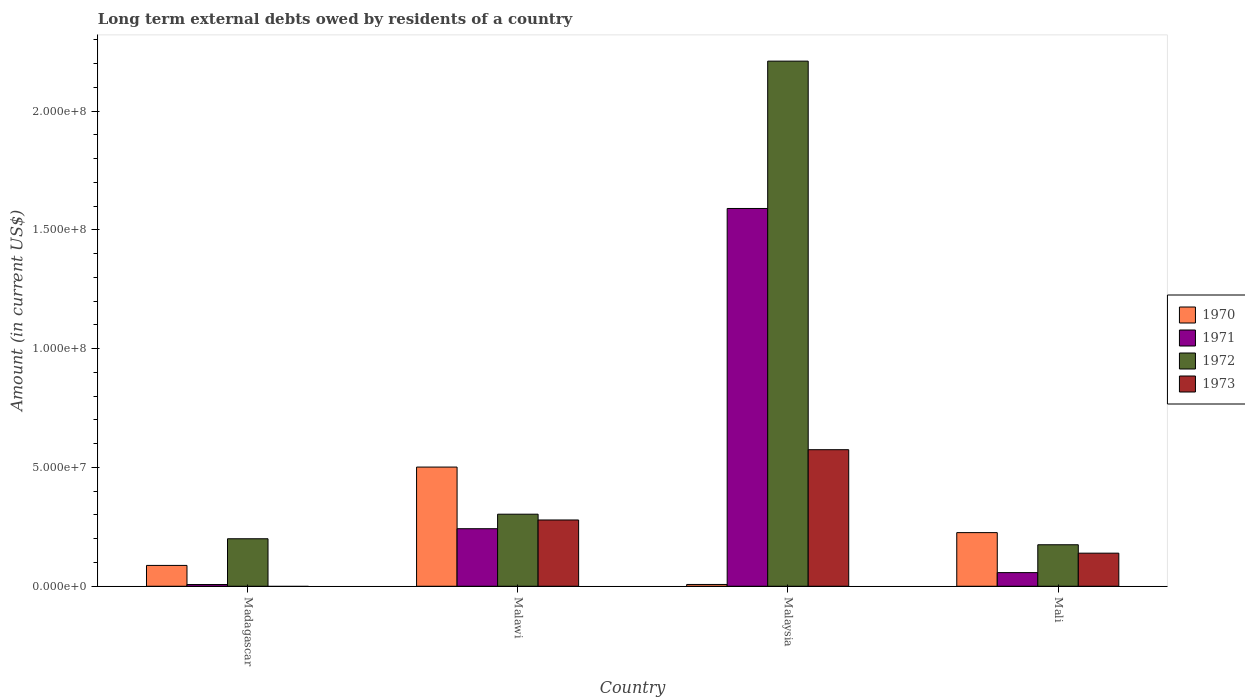How many different coloured bars are there?
Offer a terse response. 4. Are the number of bars per tick equal to the number of legend labels?
Keep it short and to the point. No. Are the number of bars on each tick of the X-axis equal?
Your response must be concise. No. What is the label of the 3rd group of bars from the left?
Make the answer very short. Malaysia. What is the amount of long-term external debts owed by residents in 1970 in Madagascar?
Make the answer very short. 8.78e+06. Across all countries, what is the maximum amount of long-term external debts owed by residents in 1971?
Your response must be concise. 1.59e+08. Across all countries, what is the minimum amount of long-term external debts owed by residents in 1971?
Provide a succinct answer. 7.30e+05. In which country was the amount of long-term external debts owed by residents in 1970 maximum?
Provide a short and direct response. Malawi. What is the total amount of long-term external debts owed by residents in 1972 in the graph?
Your answer should be very brief. 2.89e+08. What is the difference between the amount of long-term external debts owed by residents in 1971 in Malawi and that in Malaysia?
Your answer should be very brief. -1.35e+08. What is the difference between the amount of long-term external debts owed by residents in 1973 in Madagascar and the amount of long-term external debts owed by residents in 1972 in Malawi?
Your response must be concise. -3.03e+07. What is the average amount of long-term external debts owed by residents in 1971 per country?
Ensure brevity in your answer.  4.74e+07. What is the difference between the amount of long-term external debts owed by residents of/in 1972 and amount of long-term external debts owed by residents of/in 1973 in Mali?
Make the answer very short. 3.54e+06. In how many countries, is the amount of long-term external debts owed by residents in 1973 greater than 10000000 US$?
Your answer should be very brief. 3. What is the ratio of the amount of long-term external debts owed by residents in 1970 in Malawi to that in Mali?
Keep it short and to the point. 2.22. What is the difference between the highest and the second highest amount of long-term external debts owed by residents in 1972?
Your answer should be very brief. 1.91e+08. What is the difference between the highest and the lowest amount of long-term external debts owed by residents in 1971?
Your response must be concise. 1.58e+08. In how many countries, is the amount of long-term external debts owed by residents in 1973 greater than the average amount of long-term external debts owed by residents in 1973 taken over all countries?
Give a very brief answer. 2. Is it the case that in every country, the sum of the amount of long-term external debts owed by residents in 1971 and amount of long-term external debts owed by residents in 1973 is greater than the amount of long-term external debts owed by residents in 1972?
Offer a very short reply. No. Are all the bars in the graph horizontal?
Offer a very short reply. No. What is the difference between two consecutive major ticks on the Y-axis?
Your answer should be compact. 5.00e+07. Does the graph contain any zero values?
Keep it short and to the point. Yes. Where does the legend appear in the graph?
Offer a very short reply. Center right. How many legend labels are there?
Ensure brevity in your answer.  4. What is the title of the graph?
Your answer should be compact. Long term external debts owed by residents of a country. What is the label or title of the X-axis?
Your response must be concise. Country. What is the Amount (in current US$) in 1970 in Madagascar?
Provide a short and direct response. 8.78e+06. What is the Amount (in current US$) of 1971 in Madagascar?
Offer a very short reply. 7.30e+05. What is the Amount (in current US$) in 1972 in Madagascar?
Give a very brief answer. 2.00e+07. What is the Amount (in current US$) of 1973 in Madagascar?
Provide a succinct answer. 0. What is the Amount (in current US$) of 1970 in Malawi?
Make the answer very short. 5.02e+07. What is the Amount (in current US$) in 1971 in Malawi?
Your answer should be very brief. 2.42e+07. What is the Amount (in current US$) in 1972 in Malawi?
Your answer should be very brief. 3.03e+07. What is the Amount (in current US$) of 1973 in Malawi?
Your response must be concise. 2.79e+07. What is the Amount (in current US$) in 1970 in Malaysia?
Your response must be concise. 7.56e+05. What is the Amount (in current US$) of 1971 in Malaysia?
Your answer should be compact. 1.59e+08. What is the Amount (in current US$) in 1972 in Malaysia?
Give a very brief answer. 2.21e+08. What is the Amount (in current US$) of 1973 in Malaysia?
Your answer should be compact. 5.75e+07. What is the Amount (in current US$) in 1970 in Mali?
Your answer should be very brief. 2.26e+07. What is the Amount (in current US$) of 1971 in Mali?
Offer a very short reply. 5.74e+06. What is the Amount (in current US$) in 1972 in Mali?
Your answer should be compact. 1.75e+07. What is the Amount (in current US$) of 1973 in Mali?
Give a very brief answer. 1.39e+07. Across all countries, what is the maximum Amount (in current US$) of 1970?
Ensure brevity in your answer.  5.02e+07. Across all countries, what is the maximum Amount (in current US$) in 1971?
Your response must be concise. 1.59e+08. Across all countries, what is the maximum Amount (in current US$) in 1972?
Provide a succinct answer. 2.21e+08. Across all countries, what is the maximum Amount (in current US$) of 1973?
Your answer should be very brief. 5.75e+07. Across all countries, what is the minimum Amount (in current US$) of 1970?
Give a very brief answer. 7.56e+05. Across all countries, what is the minimum Amount (in current US$) of 1971?
Your answer should be very brief. 7.30e+05. Across all countries, what is the minimum Amount (in current US$) of 1972?
Offer a very short reply. 1.75e+07. Across all countries, what is the minimum Amount (in current US$) of 1973?
Offer a very short reply. 0. What is the total Amount (in current US$) in 1970 in the graph?
Provide a short and direct response. 8.23e+07. What is the total Amount (in current US$) of 1971 in the graph?
Provide a short and direct response. 1.90e+08. What is the total Amount (in current US$) in 1972 in the graph?
Provide a succinct answer. 2.89e+08. What is the total Amount (in current US$) in 1973 in the graph?
Offer a terse response. 9.93e+07. What is the difference between the Amount (in current US$) in 1970 in Madagascar and that in Malawi?
Offer a terse response. -4.14e+07. What is the difference between the Amount (in current US$) of 1971 in Madagascar and that in Malawi?
Keep it short and to the point. -2.35e+07. What is the difference between the Amount (in current US$) in 1972 in Madagascar and that in Malawi?
Offer a terse response. -1.03e+07. What is the difference between the Amount (in current US$) of 1970 in Madagascar and that in Malaysia?
Provide a short and direct response. 8.02e+06. What is the difference between the Amount (in current US$) in 1971 in Madagascar and that in Malaysia?
Your answer should be very brief. -1.58e+08. What is the difference between the Amount (in current US$) of 1972 in Madagascar and that in Malaysia?
Keep it short and to the point. -2.01e+08. What is the difference between the Amount (in current US$) in 1970 in Madagascar and that in Mali?
Your answer should be very brief. -1.38e+07. What is the difference between the Amount (in current US$) of 1971 in Madagascar and that in Mali?
Ensure brevity in your answer.  -5.01e+06. What is the difference between the Amount (in current US$) in 1972 in Madagascar and that in Mali?
Give a very brief answer. 2.52e+06. What is the difference between the Amount (in current US$) of 1970 in Malawi and that in Malaysia?
Keep it short and to the point. 4.94e+07. What is the difference between the Amount (in current US$) of 1971 in Malawi and that in Malaysia?
Offer a terse response. -1.35e+08. What is the difference between the Amount (in current US$) in 1972 in Malawi and that in Malaysia?
Keep it short and to the point. -1.91e+08. What is the difference between the Amount (in current US$) in 1973 in Malawi and that in Malaysia?
Your answer should be compact. -2.96e+07. What is the difference between the Amount (in current US$) of 1970 in Malawi and that in Mali?
Your answer should be compact. 2.76e+07. What is the difference between the Amount (in current US$) of 1971 in Malawi and that in Mali?
Give a very brief answer. 1.85e+07. What is the difference between the Amount (in current US$) in 1972 in Malawi and that in Mali?
Your response must be concise. 1.29e+07. What is the difference between the Amount (in current US$) in 1973 in Malawi and that in Mali?
Provide a short and direct response. 1.40e+07. What is the difference between the Amount (in current US$) of 1970 in Malaysia and that in Mali?
Provide a short and direct response. -2.18e+07. What is the difference between the Amount (in current US$) in 1971 in Malaysia and that in Mali?
Your response must be concise. 1.53e+08. What is the difference between the Amount (in current US$) in 1972 in Malaysia and that in Mali?
Provide a short and direct response. 2.04e+08. What is the difference between the Amount (in current US$) of 1973 in Malaysia and that in Mali?
Offer a very short reply. 4.36e+07. What is the difference between the Amount (in current US$) in 1970 in Madagascar and the Amount (in current US$) in 1971 in Malawi?
Provide a short and direct response. -1.55e+07. What is the difference between the Amount (in current US$) in 1970 in Madagascar and the Amount (in current US$) in 1972 in Malawi?
Your answer should be compact. -2.16e+07. What is the difference between the Amount (in current US$) of 1970 in Madagascar and the Amount (in current US$) of 1973 in Malawi?
Make the answer very short. -1.91e+07. What is the difference between the Amount (in current US$) of 1971 in Madagascar and the Amount (in current US$) of 1972 in Malawi?
Give a very brief answer. -2.96e+07. What is the difference between the Amount (in current US$) in 1971 in Madagascar and the Amount (in current US$) in 1973 in Malawi?
Your answer should be very brief. -2.72e+07. What is the difference between the Amount (in current US$) in 1972 in Madagascar and the Amount (in current US$) in 1973 in Malawi?
Keep it short and to the point. -7.91e+06. What is the difference between the Amount (in current US$) of 1970 in Madagascar and the Amount (in current US$) of 1971 in Malaysia?
Your answer should be very brief. -1.50e+08. What is the difference between the Amount (in current US$) of 1970 in Madagascar and the Amount (in current US$) of 1972 in Malaysia?
Your answer should be very brief. -2.12e+08. What is the difference between the Amount (in current US$) of 1970 in Madagascar and the Amount (in current US$) of 1973 in Malaysia?
Offer a very short reply. -4.87e+07. What is the difference between the Amount (in current US$) in 1971 in Madagascar and the Amount (in current US$) in 1972 in Malaysia?
Make the answer very short. -2.20e+08. What is the difference between the Amount (in current US$) in 1971 in Madagascar and the Amount (in current US$) in 1973 in Malaysia?
Offer a terse response. -5.68e+07. What is the difference between the Amount (in current US$) of 1972 in Madagascar and the Amount (in current US$) of 1973 in Malaysia?
Offer a very short reply. -3.75e+07. What is the difference between the Amount (in current US$) of 1970 in Madagascar and the Amount (in current US$) of 1971 in Mali?
Give a very brief answer. 3.04e+06. What is the difference between the Amount (in current US$) of 1970 in Madagascar and the Amount (in current US$) of 1972 in Mali?
Your answer should be compact. -8.70e+06. What is the difference between the Amount (in current US$) of 1970 in Madagascar and the Amount (in current US$) of 1973 in Mali?
Provide a short and direct response. -5.15e+06. What is the difference between the Amount (in current US$) in 1971 in Madagascar and the Amount (in current US$) in 1972 in Mali?
Give a very brief answer. -1.67e+07. What is the difference between the Amount (in current US$) in 1971 in Madagascar and the Amount (in current US$) in 1973 in Mali?
Make the answer very short. -1.32e+07. What is the difference between the Amount (in current US$) in 1972 in Madagascar and the Amount (in current US$) in 1973 in Mali?
Provide a short and direct response. 6.06e+06. What is the difference between the Amount (in current US$) in 1970 in Malawi and the Amount (in current US$) in 1971 in Malaysia?
Ensure brevity in your answer.  -1.09e+08. What is the difference between the Amount (in current US$) in 1970 in Malawi and the Amount (in current US$) in 1972 in Malaysia?
Ensure brevity in your answer.  -1.71e+08. What is the difference between the Amount (in current US$) of 1970 in Malawi and the Amount (in current US$) of 1973 in Malaysia?
Give a very brief answer. -7.31e+06. What is the difference between the Amount (in current US$) in 1971 in Malawi and the Amount (in current US$) in 1972 in Malaysia?
Your answer should be very brief. -1.97e+08. What is the difference between the Amount (in current US$) in 1971 in Malawi and the Amount (in current US$) in 1973 in Malaysia?
Provide a succinct answer. -3.33e+07. What is the difference between the Amount (in current US$) of 1972 in Malawi and the Amount (in current US$) of 1973 in Malaysia?
Make the answer very short. -2.72e+07. What is the difference between the Amount (in current US$) of 1970 in Malawi and the Amount (in current US$) of 1971 in Mali?
Your answer should be very brief. 4.44e+07. What is the difference between the Amount (in current US$) in 1970 in Malawi and the Amount (in current US$) in 1972 in Mali?
Your answer should be very brief. 3.27e+07. What is the difference between the Amount (in current US$) of 1970 in Malawi and the Amount (in current US$) of 1973 in Mali?
Keep it short and to the point. 3.62e+07. What is the difference between the Amount (in current US$) in 1971 in Malawi and the Amount (in current US$) in 1972 in Mali?
Your answer should be compact. 6.76e+06. What is the difference between the Amount (in current US$) of 1971 in Malawi and the Amount (in current US$) of 1973 in Mali?
Offer a terse response. 1.03e+07. What is the difference between the Amount (in current US$) of 1972 in Malawi and the Amount (in current US$) of 1973 in Mali?
Offer a terse response. 1.64e+07. What is the difference between the Amount (in current US$) of 1970 in Malaysia and the Amount (in current US$) of 1971 in Mali?
Keep it short and to the point. -4.98e+06. What is the difference between the Amount (in current US$) in 1970 in Malaysia and the Amount (in current US$) in 1972 in Mali?
Give a very brief answer. -1.67e+07. What is the difference between the Amount (in current US$) in 1970 in Malaysia and the Amount (in current US$) in 1973 in Mali?
Offer a very short reply. -1.32e+07. What is the difference between the Amount (in current US$) in 1971 in Malaysia and the Amount (in current US$) in 1972 in Mali?
Your answer should be very brief. 1.42e+08. What is the difference between the Amount (in current US$) of 1971 in Malaysia and the Amount (in current US$) of 1973 in Mali?
Offer a terse response. 1.45e+08. What is the difference between the Amount (in current US$) in 1972 in Malaysia and the Amount (in current US$) in 1973 in Mali?
Offer a terse response. 2.07e+08. What is the average Amount (in current US$) in 1970 per country?
Offer a terse response. 2.06e+07. What is the average Amount (in current US$) of 1971 per country?
Your response must be concise. 4.74e+07. What is the average Amount (in current US$) of 1972 per country?
Give a very brief answer. 7.22e+07. What is the average Amount (in current US$) in 1973 per country?
Make the answer very short. 2.48e+07. What is the difference between the Amount (in current US$) of 1970 and Amount (in current US$) of 1971 in Madagascar?
Give a very brief answer. 8.04e+06. What is the difference between the Amount (in current US$) in 1970 and Amount (in current US$) in 1972 in Madagascar?
Give a very brief answer. -1.12e+07. What is the difference between the Amount (in current US$) in 1971 and Amount (in current US$) in 1972 in Madagascar?
Your response must be concise. -1.93e+07. What is the difference between the Amount (in current US$) in 1970 and Amount (in current US$) in 1971 in Malawi?
Your response must be concise. 2.59e+07. What is the difference between the Amount (in current US$) of 1970 and Amount (in current US$) of 1972 in Malawi?
Give a very brief answer. 1.98e+07. What is the difference between the Amount (in current US$) of 1970 and Amount (in current US$) of 1973 in Malawi?
Your answer should be very brief. 2.23e+07. What is the difference between the Amount (in current US$) in 1971 and Amount (in current US$) in 1972 in Malawi?
Your answer should be very brief. -6.11e+06. What is the difference between the Amount (in current US$) in 1971 and Amount (in current US$) in 1973 in Malawi?
Your answer should be compact. -3.67e+06. What is the difference between the Amount (in current US$) in 1972 and Amount (in current US$) in 1973 in Malawi?
Your response must be concise. 2.43e+06. What is the difference between the Amount (in current US$) of 1970 and Amount (in current US$) of 1971 in Malaysia?
Offer a terse response. -1.58e+08. What is the difference between the Amount (in current US$) of 1970 and Amount (in current US$) of 1972 in Malaysia?
Your response must be concise. -2.20e+08. What is the difference between the Amount (in current US$) of 1970 and Amount (in current US$) of 1973 in Malaysia?
Provide a succinct answer. -5.67e+07. What is the difference between the Amount (in current US$) of 1971 and Amount (in current US$) of 1972 in Malaysia?
Give a very brief answer. -6.20e+07. What is the difference between the Amount (in current US$) in 1971 and Amount (in current US$) in 1973 in Malaysia?
Your answer should be very brief. 1.02e+08. What is the difference between the Amount (in current US$) in 1972 and Amount (in current US$) in 1973 in Malaysia?
Ensure brevity in your answer.  1.64e+08. What is the difference between the Amount (in current US$) in 1970 and Amount (in current US$) in 1971 in Mali?
Provide a succinct answer. 1.68e+07. What is the difference between the Amount (in current US$) of 1970 and Amount (in current US$) of 1972 in Mali?
Your response must be concise. 5.11e+06. What is the difference between the Amount (in current US$) in 1970 and Amount (in current US$) in 1973 in Mali?
Your answer should be very brief. 8.65e+06. What is the difference between the Amount (in current US$) in 1971 and Amount (in current US$) in 1972 in Mali?
Your answer should be compact. -1.17e+07. What is the difference between the Amount (in current US$) in 1971 and Amount (in current US$) in 1973 in Mali?
Offer a very short reply. -8.19e+06. What is the difference between the Amount (in current US$) in 1972 and Amount (in current US$) in 1973 in Mali?
Ensure brevity in your answer.  3.54e+06. What is the ratio of the Amount (in current US$) in 1970 in Madagascar to that in Malawi?
Your answer should be very brief. 0.17. What is the ratio of the Amount (in current US$) of 1971 in Madagascar to that in Malawi?
Your answer should be compact. 0.03. What is the ratio of the Amount (in current US$) of 1972 in Madagascar to that in Malawi?
Provide a succinct answer. 0.66. What is the ratio of the Amount (in current US$) of 1970 in Madagascar to that in Malaysia?
Ensure brevity in your answer.  11.61. What is the ratio of the Amount (in current US$) of 1971 in Madagascar to that in Malaysia?
Ensure brevity in your answer.  0. What is the ratio of the Amount (in current US$) in 1972 in Madagascar to that in Malaysia?
Make the answer very short. 0.09. What is the ratio of the Amount (in current US$) in 1970 in Madagascar to that in Mali?
Offer a terse response. 0.39. What is the ratio of the Amount (in current US$) of 1971 in Madagascar to that in Mali?
Provide a succinct answer. 0.13. What is the ratio of the Amount (in current US$) of 1972 in Madagascar to that in Mali?
Your answer should be very brief. 1.14. What is the ratio of the Amount (in current US$) of 1970 in Malawi to that in Malaysia?
Give a very brief answer. 66.37. What is the ratio of the Amount (in current US$) in 1971 in Malawi to that in Malaysia?
Your response must be concise. 0.15. What is the ratio of the Amount (in current US$) of 1972 in Malawi to that in Malaysia?
Ensure brevity in your answer.  0.14. What is the ratio of the Amount (in current US$) of 1973 in Malawi to that in Malaysia?
Offer a very short reply. 0.49. What is the ratio of the Amount (in current US$) of 1970 in Malawi to that in Mali?
Give a very brief answer. 2.22. What is the ratio of the Amount (in current US$) in 1971 in Malawi to that in Mali?
Offer a terse response. 4.22. What is the ratio of the Amount (in current US$) in 1972 in Malawi to that in Mali?
Offer a very short reply. 1.74. What is the ratio of the Amount (in current US$) in 1973 in Malawi to that in Mali?
Ensure brevity in your answer.  2. What is the ratio of the Amount (in current US$) of 1970 in Malaysia to that in Mali?
Provide a short and direct response. 0.03. What is the ratio of the Amount (in current US$) of 1971 in Malaysia to that in Mali?
Offer a very short reply. 27.71. What is the ratio of the Amount (in current US$) of 1972 in Malaysia to that in Mali?
Your response must be concise. 12.65. What is the ratio of the Amount (in current US$) of 1973 in Malaysia to that in Mali?
Offer a terse response. 4.13. What is the difference between the highest and the second highest Amount (in current US$) of 1970?
Offer a terse response. 2.76e+07. What is the difference between the highest and the second highest Amount (in current US$) of 1971?
Ensure brevity in your answer.  1.35e+08. What is the difference between the highest and the second highest Amount (in current US$) in 1972?
Provide a short and direct response. 1.91e+08. What is the difference between the highest and the second highest Amount (in current US$) in 1973?
Keep it short and to the point. 2.96e+07. What is the difference between the highest and the lowest Amount (in current US$) in 1970?
Your answer should be very brief. 4.94e+07. What is the difference between the highest and the lowest Amount (in current US$) of 1971?
Offer a very short reply. 1.58e+08. What is the difference between the highest and the lowest Amount (in current US$) in 1972?
Your answer should be very brief. 2.04e+08. What is the difference between the highest and the lowest Amount (in current US$) in 1973?
Make the answer very short. 5.75e+07. 